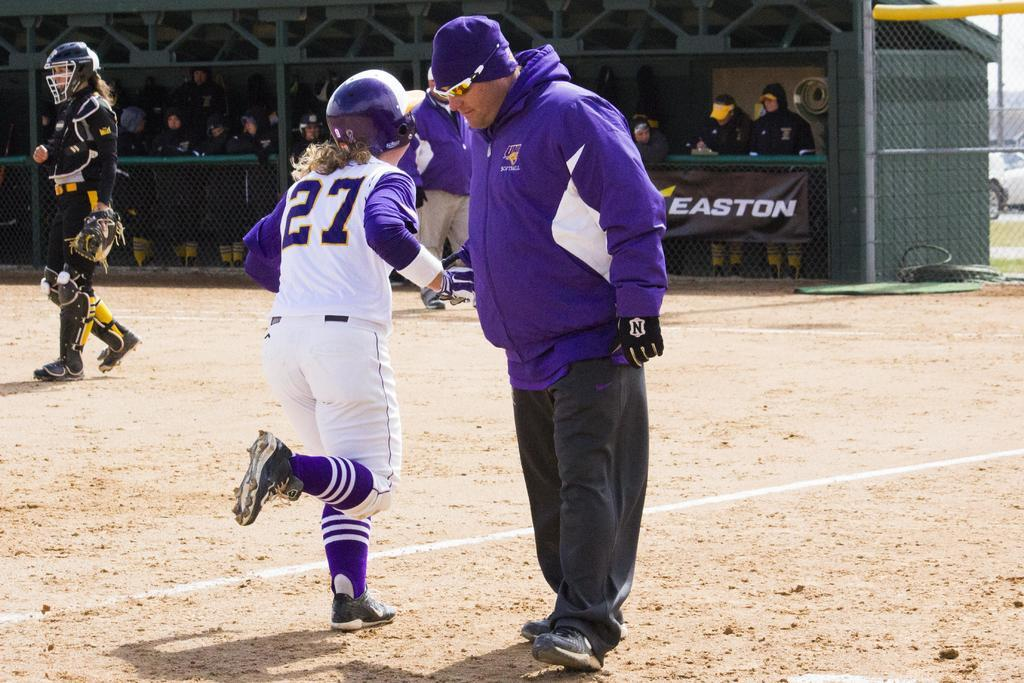<image>
Present a compact description of the photo's key features. A baseball player running past their coach with Easton in the background 